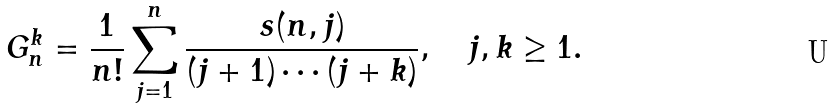<formula> <loc_0><loc_0><loc_500><loc_500>G _ { n } ^ { k } = \frac { 1 } { n ! } \sum _ { j = 1 } ^ { n } \frac { s ( n , j ) } { ( j + 1 ) \cdots ( j + k ) } , \quad j , k \geq 1 .</formula> 